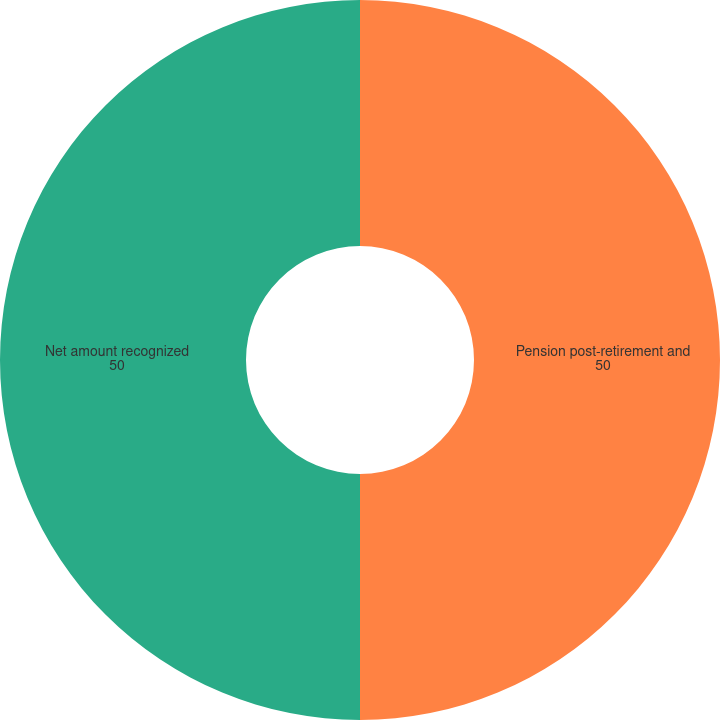Convert chart. <chart><loc_0><loc_0><loc_500><loc_500><pie_chart><fcel>Pension post-retirement and<fcel>Net amount recognized<nl><fcel>50.0%<fcel>50.0%<nl></chart> 